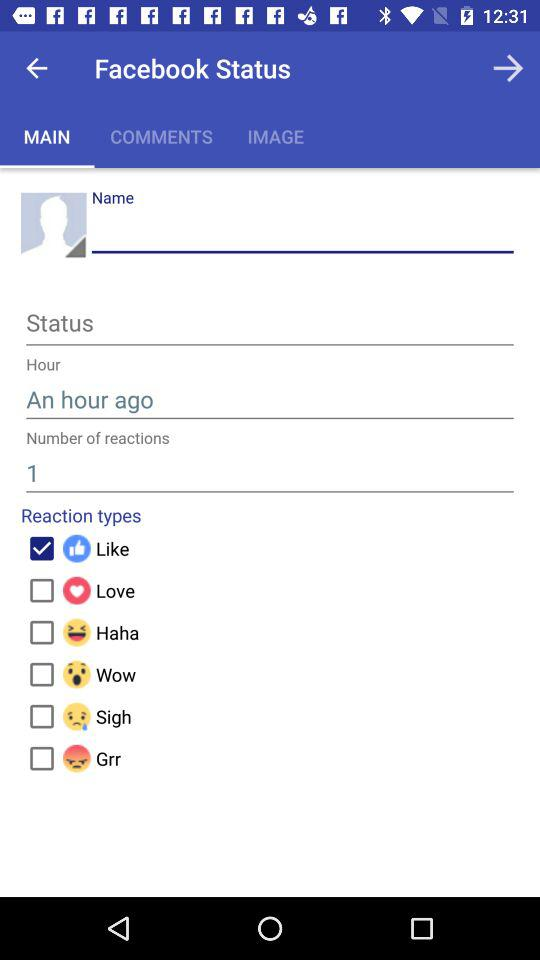What is the number of reactions? The number of reaction is 1. 